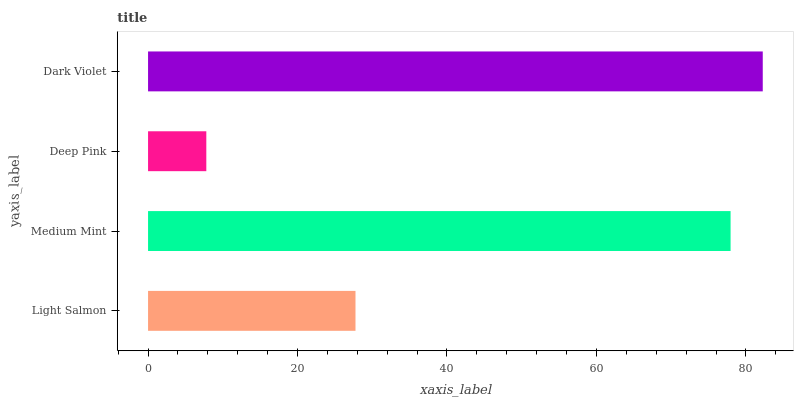Is Deep Pink the minimum?
Answer yes or no. Yes. Is Dark Violet the maximum?
Answer yes or no. Yes. Is Medium Mint the minimum?
Answer yes or no. No. Is Medium Mint the maximum?
Answer yes or no. No. Is Medium Mint greater than Light Salmon?
Answer yes or no. Yes. Is Light Salmon less than Medium Mint?
Answer yes or no. Yes. Is Light Salmon greater than Medium Mint?
Answer yes or no. No. Is Medium Mint less than Light Salmon?
Answer yes or no. No. Is Medium Mint the high median?
Answer yes or no. Yes. Is Light Salmon the low median?
Answer yes or no. Yes. Is Light Salmon the high median?
Answer yes or no. No. Is Deep Pink the low median?
Answer yes or no. No. 